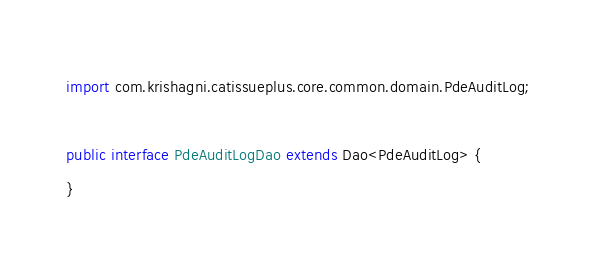<code> <loc_0><loc_0><loc_500><loc_500><_Java_>
import com.krishagni.catissueplus.core.common.domain.PdeAuditLog;

public interface PdeAuditLogDao extends Dao<PdeAuditLog> {
}
</code> 